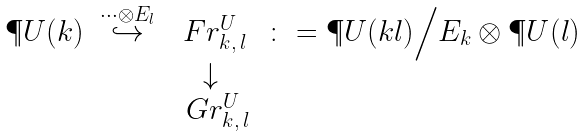Convert formula to latex. <formula><loc_0><loc_0><loc_500><loc_500>\begin{array} { c c c c } \P U ( k ) & \stackrel { \cdots \otimes E _ { l } } { \hookrightarrow } & \ F r ^ { U } _ { k , \, l } & \colon = \P U ( k l ) \Big / E _ { k } \otimes \P U ( l ) \quad \\ & & \downarrow \\ & & \, \ G r ^ { U } _ { k , \, l } \end{array}</formula> 